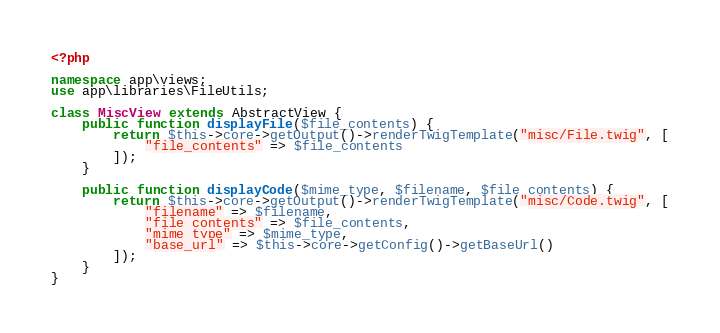Convert code to text. <code><loc_0><loc_0><loc_500><loc_500><_PHP_><?php

namespace app\views;
use app\libraries\FileUtils;

class MiscView extends AbstractView {
    public function displayFile($file_contents) {
        return $this->core->getOutput()->renderTwigTemplate("misc/File.twig", [
            "file_contents" => $file_contents
        ]);
    }

    public function displayCode($mime_type, $filename, $file_contents) {
        return $this->core->getOutput()->renderTwigTemplate("misc/Code.twig", [
            "filename" => $filename,
            "file_contents" => $file_contents,
            "mime_type" => $mime_type,
            "base_url" => $this->core->getConfig()->getBaseUrl()
        ]);
	}
}
</code> 